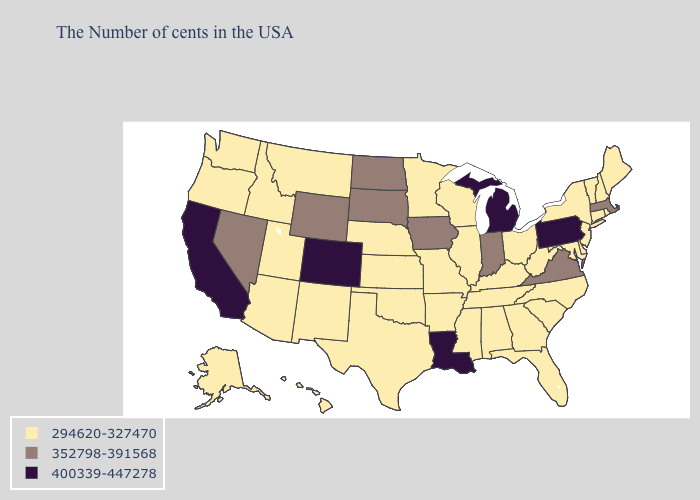Among the states that border Tennessee , does Alabama have the highest value?
Keep it brief. No. Which states have the lowest value in the USA?
Short answer required. Maine, Rhode Island, New Hampshire, Vermont, Connecticut, New York, New Jersey, Delaware, Maryland, North Carolina, South Carolina, West Virginia, Ohio, Florida, Georgia, Kentucky, Alabama, Tennessee, Wisconsin, Illinois, Mississippi, Missouri, Arkansas, Minnesota, Kansas, Nebraska, Oklahoma, Texas, New Mexico, Utah, Montana, Arizona, Idaho, Washington, Oregon, Alaska, Hawaii. Among the states that border Wisconsin , does Illinois have the lowest value?
Keep it brief. Yes. What is the lowest value in the West?
Give a very brief answer. 294620-327470. Name the states that have a value in the range 352798-391568?
Write a very short answer. Massachusetts, Virginia, Indiana, Iowa, South Dakota, North Dakota, Wyoming, Nevada. Is the legend a continuous bar?
Answer briefly. No. Does Montana have the same value as Idaho?
Quick response, please. Yes. What is the value of Michigan?
Short answer required. 400339-447278. Name the states that have a value in the range 400339-447278?
Be succinct. Pennsylvania, Michigan, Louisiana, Colorado, California. Among the states that border Arkansas , which have the lowest value?
Keep it brief. Tennessee, Mississippi, Missouri, Oklahoma, Texas. How many symbols are there in the legend?
Concise answer only. 3. Which states have the highest value in the USA?
Write a very short answer. Pennsylvania, Michigan, Louisiana, Colorado, California. How many symbols are there in the legend?
Be succinct. 3. Name the states that have a value in the range 352798-391568?
Keep it brief. Massachusetts, Virginia, Indiana, Iowa, South Dakota, North Dakota, Wyoming, Nevada. 